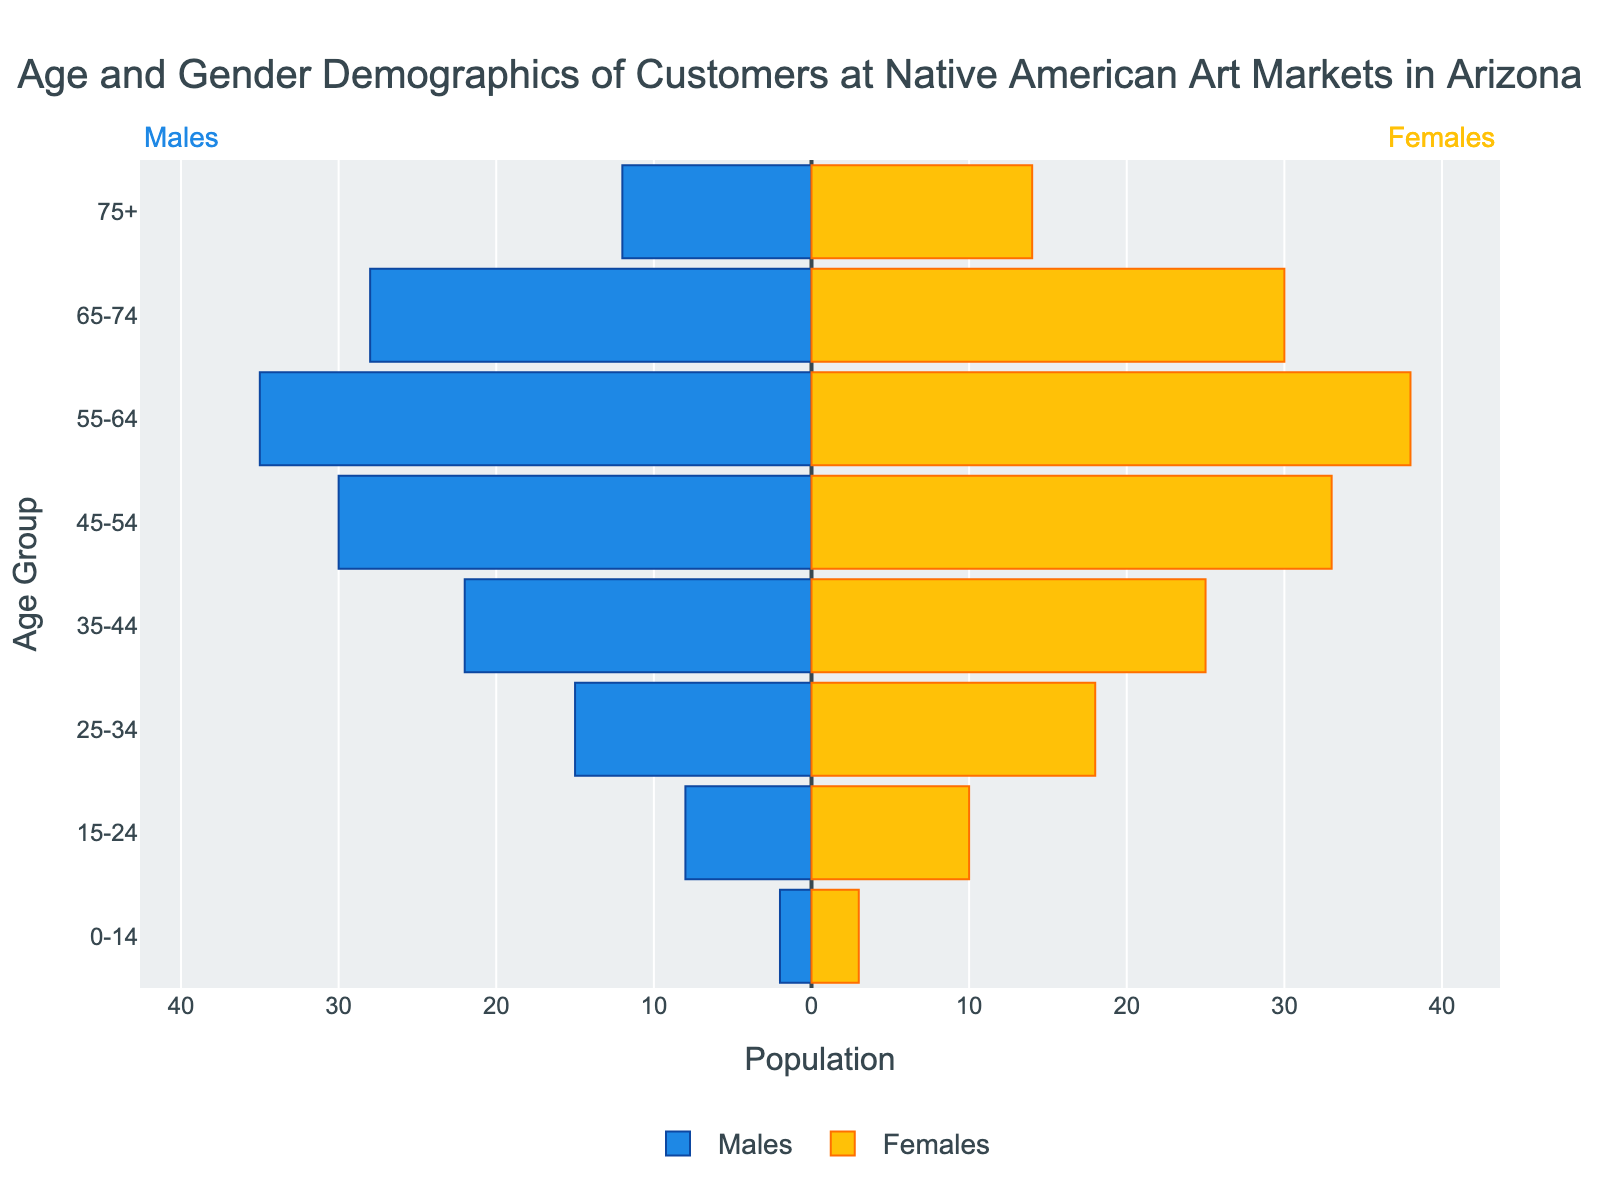What is the title of the figure? The title is displayed at the top of the figure and provides a description of what the figure represents.
Answer: Age and Gender Demographics of Customers at Native American Art Markets in Arizona How many age groups are shown in the figure? Count the number of distinct age groups mentioned on the y-axis.
Answer: 8 What color represents the male customers in the figure? Look at the color of the bars labeled 'Males' in the legend.
Answer: Blue How many female customers are in the 55-64 age group? Locate the bar for the 55-64 age group on the y-axis and read the value for the Females bar, which is represented by yellow.
Answer: 38 Which age group has the highest number of male customers? Identify the age group with the longest blue bar extending to the left.
Answer: 55-64 What is the total number of customers in the 45-54 age group? Add the number of male and female customers in the 45-54 age group together (30 Males + 33 Females).
Answer: 63 How does the number of female customers compare between the 35-44 age group and the 75+ age group? Compare the length of the yellow bars for the 35-44 and 75+ age groups.
Answer: Higher in the 35-44 age group What is the average number of customers (both genders combined) for the 25-34 and 35-44 age groups? Calculate the total number of customers for each age group and find the average:
(15 Males + 18 Females) for 25-34 = 33
(22 Males + 25 Females) for 35-44 = 47
Now, calculate the average: (33 + 47) / 2.
Answer: 40 What is the male-to-female ratio in the 65-74 age group? Find the number of males and females in the 65-74 age group and calculate the ratio:
Males: 28, Females: 30. The ratio is 28:30, which simplifies to 14:15.
Answer: 14:15 